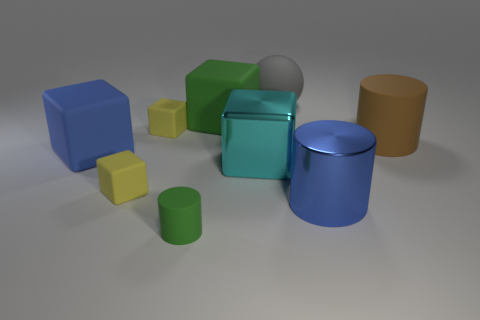There is a big rubber thing that is on the left side of the big green rubber thing; what number of large blue metallic things are right of it?
Make the answer very short. 1. There is a big rubber thing behind the large green rubber thing; is it the same shape as the big blue object that is on the right side of the large cyan metal object?
Your answer should be compact. No. How big is the rubber thing that is both to the right of the green rubber cube and on the left side of the big blue cylinder?
Offer a terse response. Large. The metallic thing that is the same shape as the small green matte object is what color?
Your answer should be very brief. Blue. What is the color of the cylinder that is to the left of the rubber block right of the green matte cylinder?
Provide a short and direct response. Green. The big green thing has what shape?
Your answer should be compact. Cube. What shape is the big object that is both behind the big brown cylinder and on the left side of the large gray matte sphere?
Your answer should be compact. Cube. The sphere that is the same material as the brown thing is what color?
Make the answer very short. Gray. What shape is the large matte object that is on the left side of the yellow rubber thing that is to the right of the small yellow object in front of the large blue block?
Your answer should be very brief. Cube. The brown matte object is what size?
Offer a terse response. Large. 